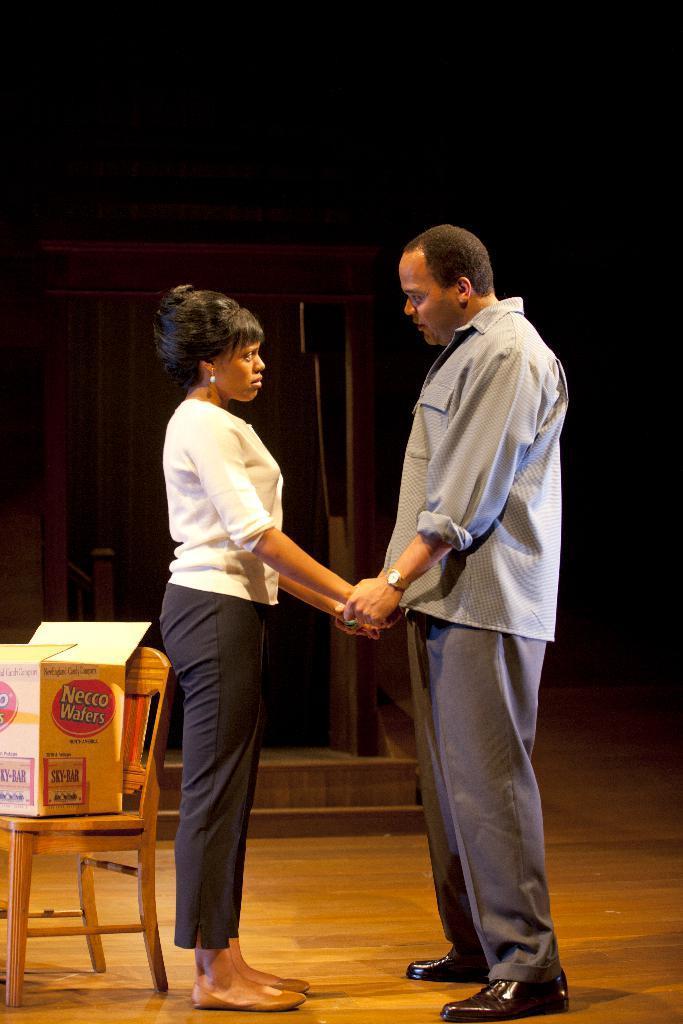Can you describe this image briefly? In the picture there is a person and a woman standing opposite to each other by holding the hands near to the women there is a chair on the chair there is a cardboard box with the text on it. 